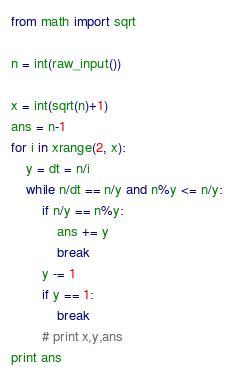<code> <loc_0><loc_0><loc_500><loc_500><_Python_>from math import sqrt 

n = int(raw_input())

x = int(sqrt(n)+1)
ans = n-1
for i in xrange(2, x):
    y = dt = n/i
    while n/dt == n/y and n%y <= n/y:
        if n/y == n%y:
            ans += y
            break
        y -= 1
        if y == 1:
            break
        # print x,y,ans
print ans</code> 